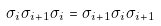<formula> <loc_0><loc_0><loc_500><loc_500>\sigma _ { i } \sigma _ { i + 1 } \sigma _ { i } = \sigma _ { i + 1 } \sigma _ { i } \sigma _ { i + 1 }</formula> 